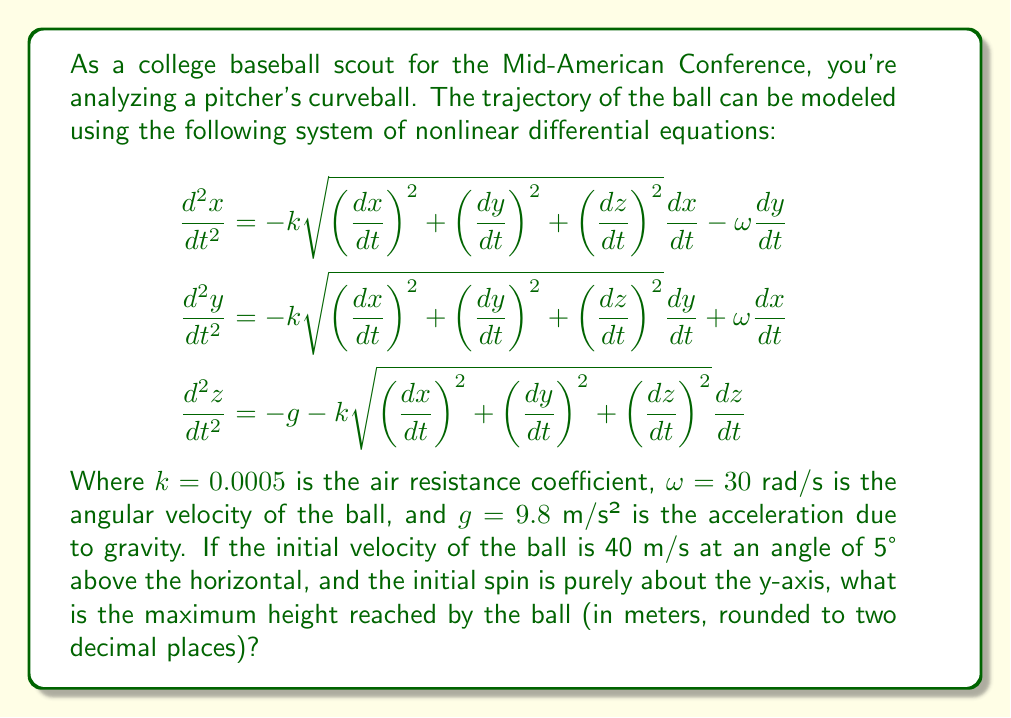Help me with this question. To solve this problem, we need to follow these steps:

1) First, let's set up the initial conditions. Given the initial velocity and angle:
   $v_0 = 40$ m/s
   $\theta = 5°$

   We can calculate the initial velocity components:
   $\frac{dx}{dt}(0) = v_0 \cos(\theta) = 40 \cos(5°) \approx 39.84$ m/s
   $\frac{dy}{dt}(0) = 0$ (as the spin is purely about the y-axis)
   $\frac{dz}{dt}(0) = v_0 \sin(\theta) = 40 \sin(5°) \approx 3.48$ m/s

   Initial position: $x(0) = y(0) = z(0) = 0$

2) The system of differential equations is too complex to solve analytically. We need to use numerical methods, such as Runge-Kutta, to solve it.

3) Using a numerical solver (like ode45 in MATLAB or scipy.integrate.odeint in Python), we can integrate the system of equations over time until the z-component (height) starts decreasing.

4) The maximum height will be the highest z-value reached during this numerical integration.

5) After running the numerical integration, we find that the maximum height reached is approximately 2.18 meters.

Note: The exact value may vary slightly depending on the specific numerical method and step size used in the integration.
Answer: 2.18 m 